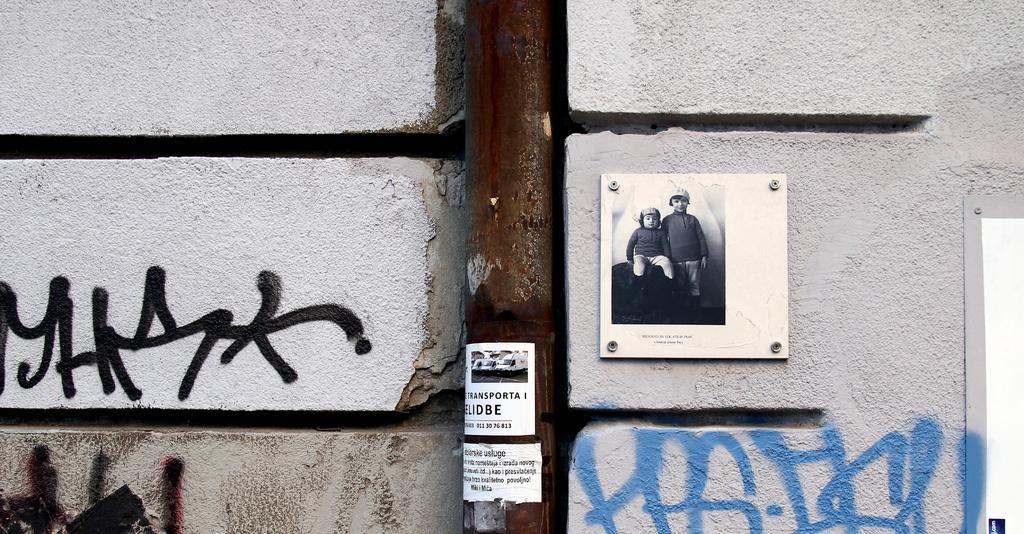In one or two sentences, can you explain what this image depicts? In this image we can see, there is a wall and a photo is on the wall , we can see pole ,poster. 